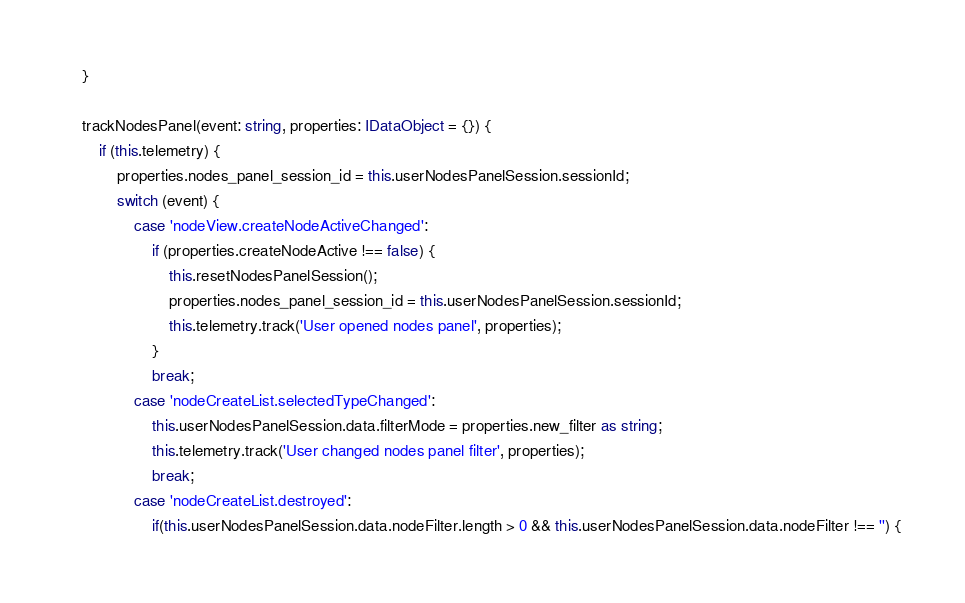Convert code to text. <code><loc_0><loc_0><loc_500><loc_500><_TypeScript_>	}

	trackNodesPanel(event: string, properties: IDataObject = {}) {
		if (this.telemetry) {
			properties.nodes_panel_session_id = this.userNodesPanelSession.sessionId;
			switch (event) {
				case 'nodeView.createNodeActiveChanged':
					if (properties.createNodeActive !== false) {
						this.resetNodesPanelSession();
						properties.nodes_panel_session_id = this.userNodesPanelSession.sessionId;
						this.telemetry.track('User opened nodes panel', properties);
					}
					break;
				case 'nodeCreateList.selectedTypeChanged':
					this.userNodesPanelSession.data.filterMode = properties.new_filter as string;
					this.telemetry.track('User changed nodes panel filter', properties);
					break;
				case 'nodeCreateList.destroyed':
					if(this.userNodesPanelSession.data.nodeFilter.length > 0 && this.userNodesPanelSession.data.nodeFilter !== '') {</code> 